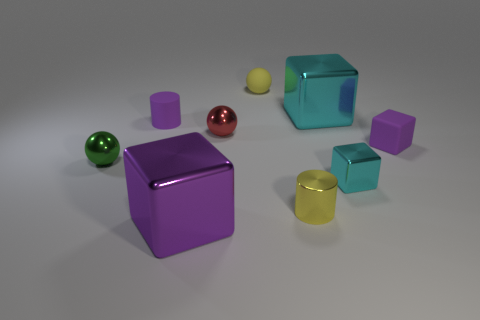Is the red object made of the same material as the yellow sphere?
Offer a terse response. No. How many small matte things are the same color as the tiny rubber cube?
Your answer should be very brief. 1. Is the small metallic cylinder the same color as the small matte cylinder?
Your response must be concise. No. There is a big cube that is behind the purple shiny thing; what is its material?
Offer a terse response. Metal. What number of large objects are purple shiny objects or things?
Offer a very short reply. 2. There is a tiny object that is the same color as the tiny shiny cylinder; what is its material?
Your response must be concise. Rubber. Are there any yellow balls that have the same material as the purple cylinder?
Give a very brief answer. Yes. Is the size of the metal ball left of the purple cylinder the same as the small rubber sphere?
Offer a terse response. Yes. There is a large shiny thing that is on the left side of the large thing to the right of the tiny matte ball; are there any big metallic blocks that are in front of it?
Make the answer very short. No. What number of metallic things are either cyan blocks or yellow cubes?
Make the answer very short. 2. 